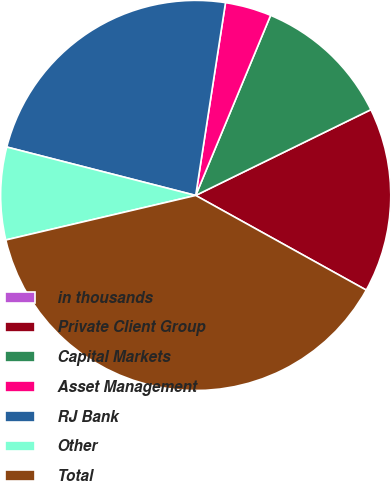<chart> <loc_0><loc_0><loc_500><loc_500><pie_chart><fcel>in thousands<fcel>Private Client Group<fcel>Capital Markets<fcel>Asset Management<fcel>RJ Bank<fcel>Other<fcel>Total<nl><fcel>0.0%<fcel>15.31%<fcel>11.48%<fcel>3.83%<fcel>23.45%<fcel>7.66%<fcel>38.27%<nl></chart> 